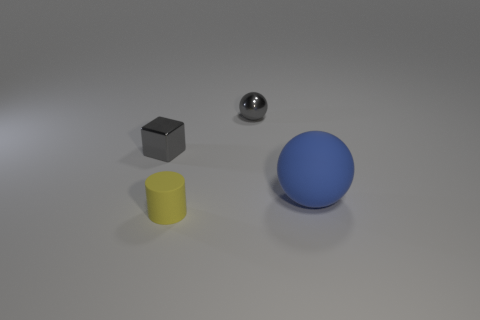Subtract 1 balls. How many balls are left? 1 Add 2 cyan metallic cylinders. How many objects exist? 6 Subtract all brown balls. Subtract all blue cylinders. How many balls are left? 2 Subtract all yellow balls. How many gray cylinders are left? 0 Subtract all blue matte balls. Subtract all gray metallic objects. How many objects are left? 1 Add 3 yellow cylinders. How many yellow cylinders are left? 4 Add 4 purple cylinders. How many purple cylinders exist? 4 Subtract 1 gray blocks. How many objects are left? 3 